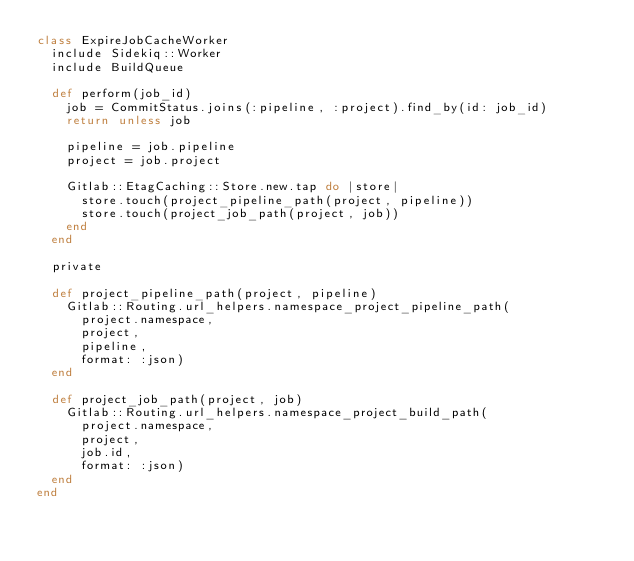<code> <loc_0><loc_0><loc_500><loc_500><_Ruby_>class ExpireJobCacheWorker
  include Sidekiq::Worker
  include BuildQueue

  def perform(job_id)
    job = CommitStatus.joins(:pipeline, :project).find_by(id: job_id)
    return unless job

    pipeline = job.pipeline
    project = job.project

    Gitlab::EtagCaching::Store.new.tap do |store|
      store.touch(project_pipeline_path(project, pipeline))
      store.touch(project_job_path(project, job))
    end
  end

  private

  def project_pipeline_path(project, pipeline)
    Gitlab::Routing.url_helpers.namespace_project_pipeline_path(
      project.namespace,
      project,
      pipeline,
      format: :json)
  end

  def project_job_path(project, job)
    Gitlab::Routing.url_helpers.namespace_project_build_path(
      project.namespace,
      project,
      job.id,
      format: :json)
  end
end
</code> 